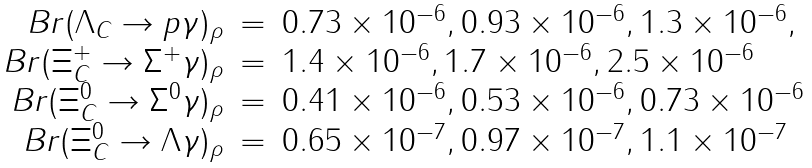<formula> <loc_0><loc_0><loc_500><loc_500>\begin{array} { r c l } B r ( \Lambda _ { C } \rightarrow p \gamma ) _ { \rho } & = & 0 . 7 3 \times 1 0 ^ { - 6 } , 0 . 9 3 \times 1 0 ^ { - 6 } , 1 . 3 \times 1 0 ^ { - 6 } , \\ B r ( \Xi _ { C } ^ { + } \rightarrow \Sigma ^ { + } \gamma ) _ { \rho } & = & 1 . 4 \times 1 0 ^ { - 6 } , 1 . 7 \times 1 0 ^ { - 6 } , 2 . 5 \times 1 0 ^ { - 6 } \\ B r ( \Xi _ { C } ^ { 0 } \rightarrow \Sigma ^ { 0 } \gamma ) _ { \rho } & = & 0 . 4 1 \times 1 0 ^ { - 6 } , 0 . 5 3 \times 1 0 ^ { - 6 } , 0 . 7 3 \times 1 0 ^ { - 6 } \\ B r ( \Xi _ { C } ^ { 0 } \rightarrow \Lambda \gamma ) _ { \rho } & = & 0 . 6 5 \times 1 0 ^ { - 7 } , 0 . 9 7 \times 1 0 ^ { - 7 } , 1 . 1 \times 1 0 ^ { - 7 } \end{array}</formula> 